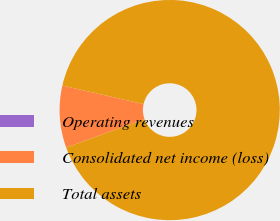<chart> <loc_0><loc_0><loc_500><loc_500><pie_chart><fcel>Operating revenues<fcel>Consolidated net income (loss)<fcel>Total assets<nl><fcel>0.01%<fcel>9.1%<fcel>90.89%<nl></chart> 